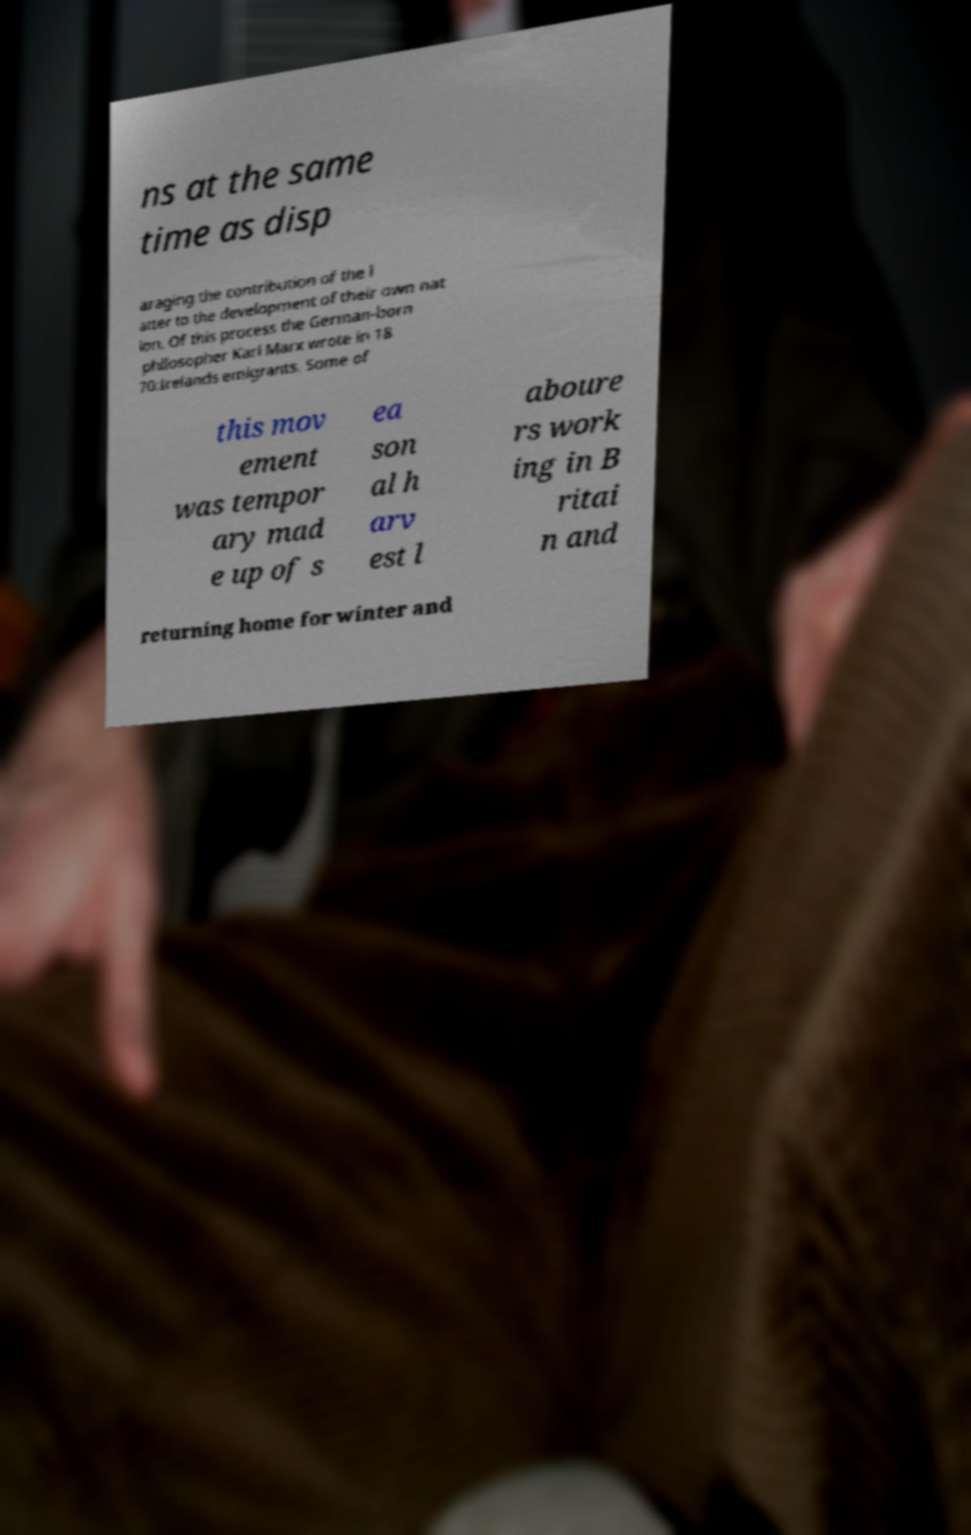Could you assist in decoding the text presented in this image and type it out clearly? ns at the same time as disp araging the contribution of the l atter to the development of their own nat ion. Of this process the German-born philosopher Karl Marx wrote in 18 70:Irelands emigrants. Some of this mov ement was tempor ary mad e up of s ea son al h arv est l aboure rs work ing in B ritai n and returning home for winter and 